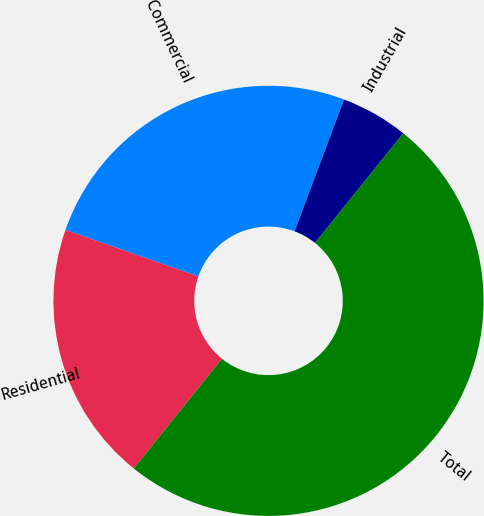Convert chart to OTSL. <chart><loc_0><loc_0><loc_500><loc_500><pie_chart><fcel>Residential<fcel>Commercial<fcel>Industrial<fcel>Total<nl><fcel>19.58%<fcel>25.36%<fcel>5.07%<fcel>50.0%<nl></chart> 